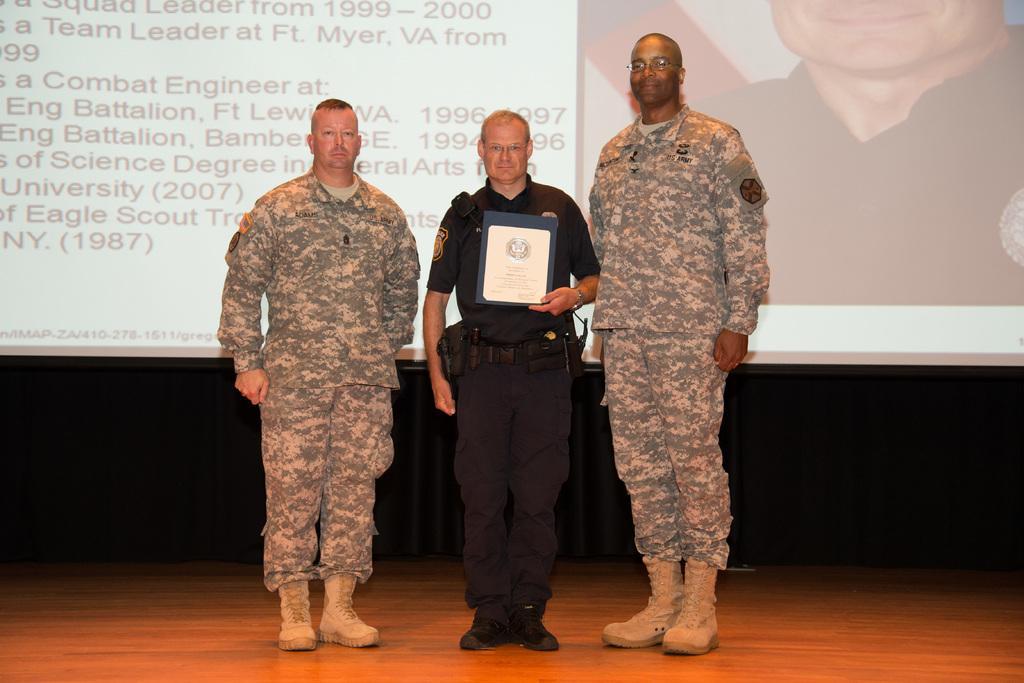Describe this image in one or two sentences. In the picture I can see three men standing on the wooden floor and the man in the middle is holding the memento shield in his left hand. In the background, I can see the screen. On the screen I can see the photo of a man and text. 